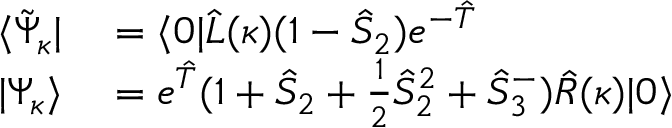<formula> <loc_0><loc_0><loc_500><loc_500>\begin{array} { r l } { \langle \tilde { \Psi } _ { \kappa } | } & = \langle 0 | \hat { L } ( \kappa ) ( 1 - \hat { S } _ { 2 } ) e ^ { - \hat { T } } } \\ { | \Psi _ { \kappa } \rangle } & = e ^ { \hat { T } } ( 1 + \hat { S } _ { 2 } + \frac { 1 } { 2 } \hat { S } _ { 2 } ^ { 2 } + \hat { S } _ { 3 } ^ { - } ) \hat { R } ( \kappa ) | 0 \rangle } \end{array}</formula> 